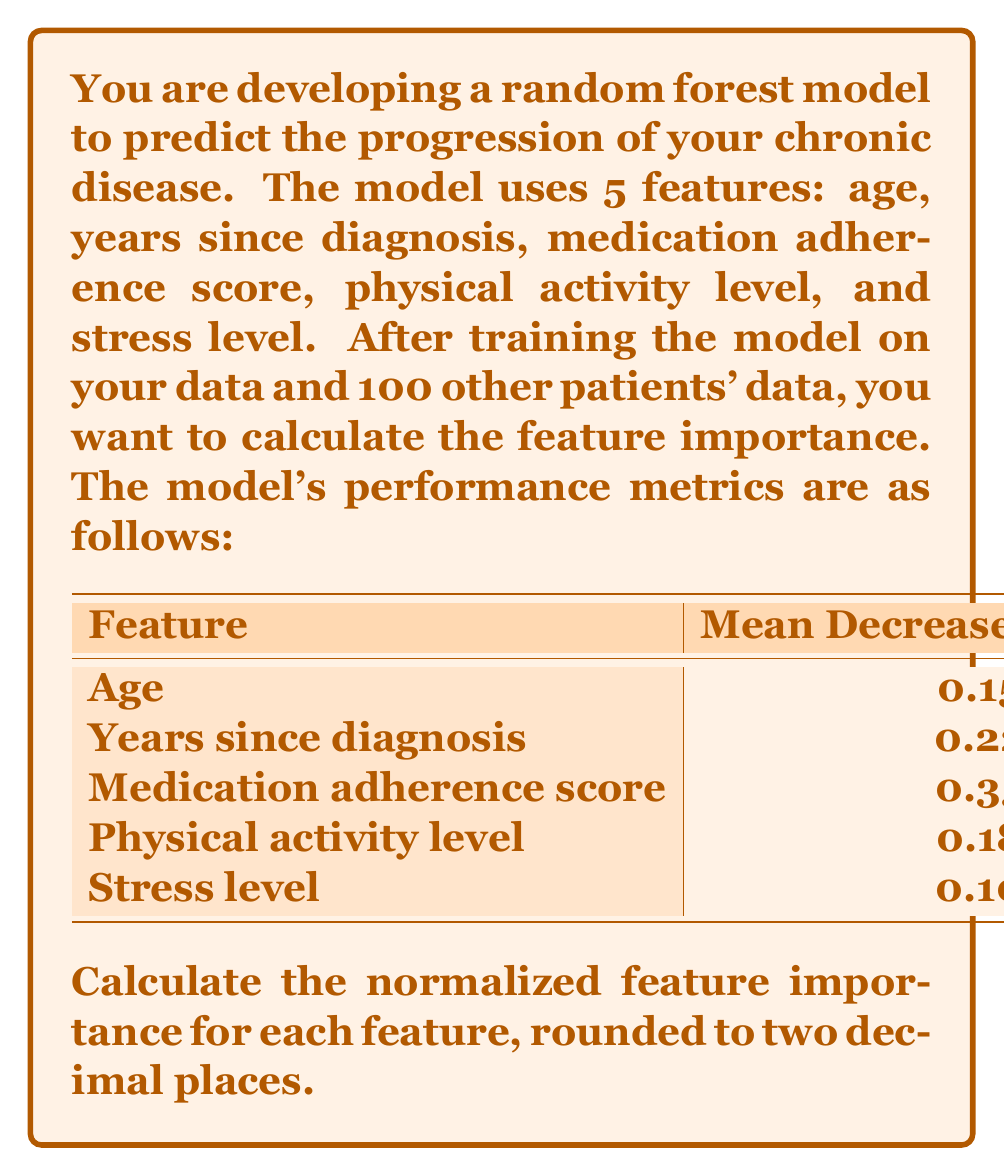Teach me how to tackle this problem. To calculate the normalized feature importance, we follow these steps:

1. Sum up all the Mean Decrease in Impurity values:
   $$0.15 + 0.22 + 0.35 + 0.18 + 0.10 = 1.00$$

2. Divide each feature's Mean Decrease in Impurity by the sum to get the normalized importance:

   For Age:
   $$\frac{0.15}{1.00} = 0.15$$

   For Years since diagnosis:
   $$\frac{0.22}{1.00} = 0.22$$

   For Medication adherence score:
   $$\frac{0.35}{1.00} = 0.35$$

   For Physical activity level:
   $$\frac{0.18}{1.00} = 0.18$$

   For Stress level:
   $$\frac{0.10}{1.00} = 0.10$$

3. Round each result to two decimal places.

The normalized feature importance gives us a measure of how much each feature contributes to the model's predictive power, with all values summing to 1.
Answer: The normalized feature importance for each feature, rounded to two decimal places:

Age: 0.15
Years since diagnosis: 0.22
Medication adherence score: 0.35
Physical activity level: 0.18
Stress level: 0.10 